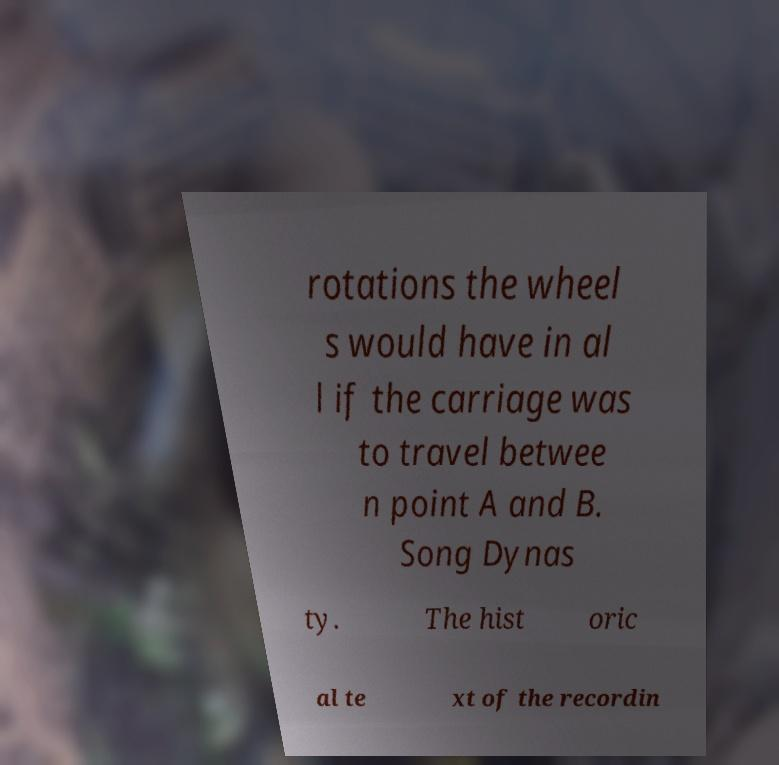Can you read and provide the text displayed in the image?This photo seems to have some interesting text. Can you extract and type it out for me? rotations the wheel s would have in al l if the carriage was to travel betwee n point A and B. Song Dynas ty. The hist oric al te xt of the recordin 